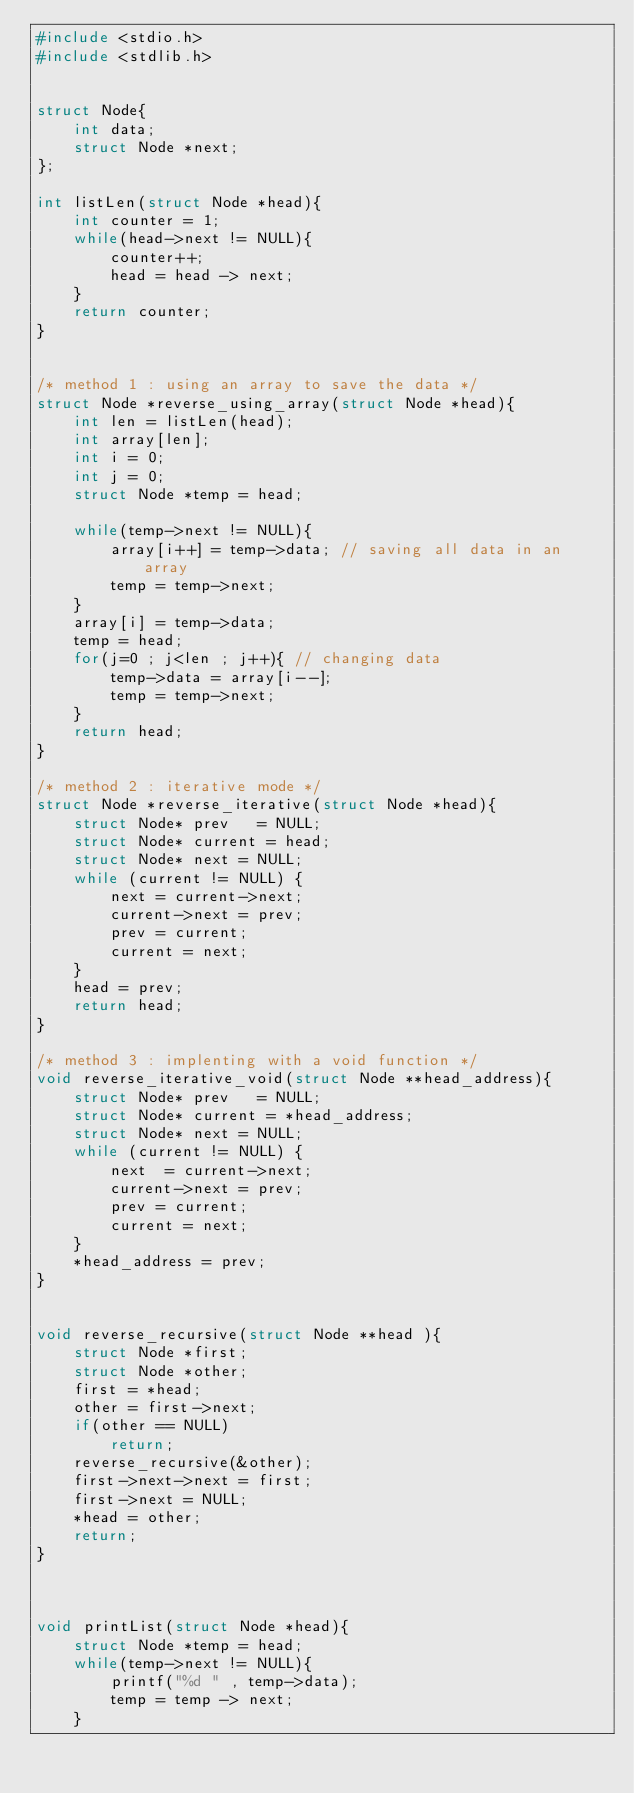Convert code to text. <code><loc_0><loc_0><loc_500><loc_500><_C_>#include <stdio.h>
#include <stdlib.h>


struct Node{
    int data;
    struct Node *next;
};

int listLen(struct Node *head){
    int counter = 1;
    while(head->next != NULL){
        counter++;
        head = head -> next;
    }
    return counter;
}


/* method 1 : using an array to save the data */
struct Node *reverse_using_array(struct Node *head){
    int len = listLen(head);
    int array[len];
    int i = 0;
    int j = 0;
    struct Node *temp = head;
    
    while(temp->next != NULL){
        array[i++] = temp->data; // saving all data in an array
        temp = temp->next;
    }
    array[i] = temp->data;
    temp = head;
    for(j=0 ; j<len ; j++){ // changing data
        temp->data = array[i--];
        temp = temp->next;
    }
    return head;
}

/* method 2 : iterative mode */
struct Node *reverse_iterative(struct Node *head){
    struct Node* prev   = NULL; 
    struct Node* current = head; 
    struct Node* next = NULL; 
    while (current != NULL) { 
        next = current->next;   
        current->next = prev;    
        prev = current; 
        current = next; 
    } 
    head = prev; 
    return head;
}

/* method 3 : implenting with a void function */ 
void reverse_iterative_void(struct Node **head_address){
    struct Node* prev   = NULL; 
    struct Node* current = *head_address; 
    struct Node* next = NULL; 
    while (current != NULL) { 
        next  = current->next;   
        current->next = prev;    
        prev = current; 
        current = next; 
    } 
    *head_address = prev; 
}


void reverse_recursive(struct Node **head ){
    struct Node *first;
    struct Node *other;
    first = *head;
    other = first->next;
    if(other == NULL)
        return;
    reverse_recursive(&other);
    first->next->next = first;
    first->next = NULL;
    *head = other;
    return;
}



void printList(struct Node *head){
    struct Node *temp = head;
    while(temp->next != NULL){
        printf("%d " , temp->data);
        temp = temp -> next;
    }</code> 